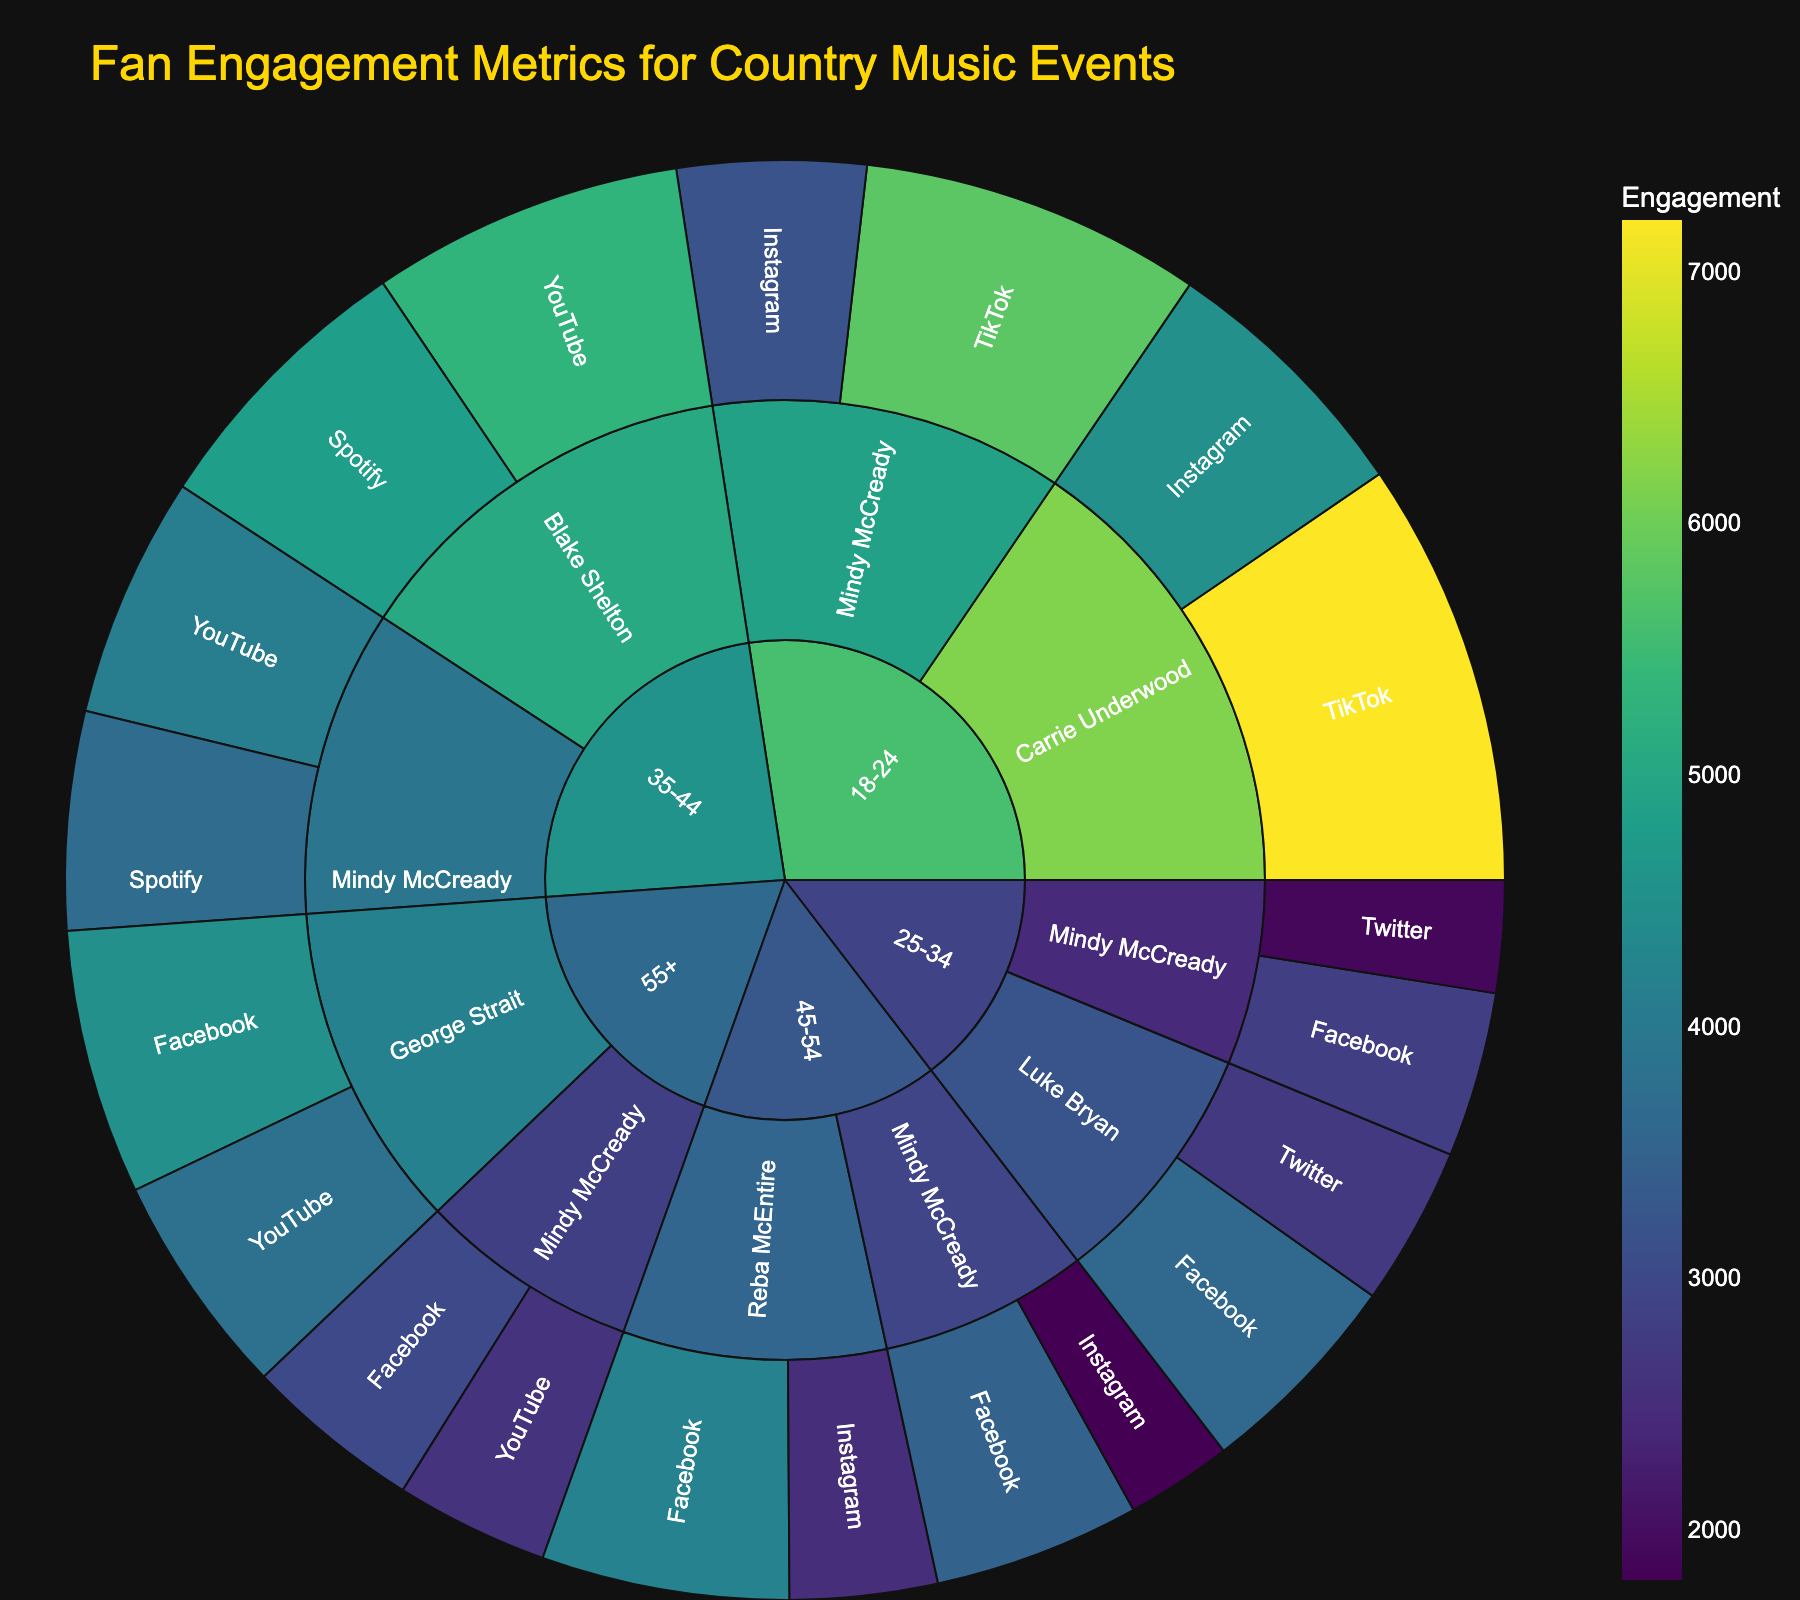What's the title of the figure? Look at the top of the figure where the title is displayed in gold color.
Answer: "Fan Engagement Metrics for Country Music Events" Which age group has the highest engagement on TikTok for Mindy McCready? Locate Mindy McCready in the Sunburst plot and navigate to the platform TikTok. The highest value can be seen for the 18-24 age group which has 5800 engagements.
Answer: 18-24 How many social media platforms are represented in the figure? Observe the different platforms listed under each artist. Count unique platforms: Instagram, TikTok, Facebook, Twitter, YouTube, and Spotify.
Answer: 6 What is the total engagement for Mindy McCready across all age groups? Sum up the engagements for Mindy McCready across all age groups and platforms: 3200 + 5800 + 2800 + 1900 + 4100 + 3700 + 3500 + 1800 + 2600 + 3000. The total engagement is 32,400.
Answer: 32,400 Which artist has the highest engagement in the 25-34 age group on Facebook? Identify the artist with the highest engagement on Facebook within the 25-34 age group. Compare the values: Mindy McCready (2800) and Luke Bryan (3600). Luke Bryan has the highest engagement.
Answer: Luke Bryan Among the 45-54 age group, which platform has the lowest engagement for Reba McEntire? Identify Reba McEntire in the 45-54 age group and compare the engagement on Facebook (4200) and Instagram (2500). Instagram has the lowest engagement.
Answer: Instagram What is the combined engagement for Luke Bryan and Blake Shelton across all platforms? Sum up engagements for Luke Bryan (3600 + 2700) and Blake Shelton (5300 + 4800): 3600 + 2700 + 5300 + 4800 = 16,400.
Answer: 16,400 Which age group shows the highest engagement for George Strait on Facebook? Locate George Strait in the figure, identifying the engagement for the 55+ age group on Facebook which is 4500.
Answer: 55+ Compare the engagement on YouTube for Mindy McCready and Blake Shelton in the 35-44 age group. Who has the higher engagement and by how much? Find the engagement values for each artist: Mindy McCready (4100) and Blake Shelton (5300). Compute the difference: 5300 - 4100 = 1200. Blake Shelton has a higher engagement by 1200.
Answer: Blake Shelton by 1200 What proportion of total engagement does Instagram have for the 18-24 age group compared to all platforms in that age group? Sum all engagements in the 18-24 group (3200 + 5800 + 4500 + 7200 = 20700). Note Instagram's engagements (3200 + 4500 = 7700). Calculate the proportion: 7700 / 20700 ≈ 0.3725 or 37.25%.
Answer: 37.25% 